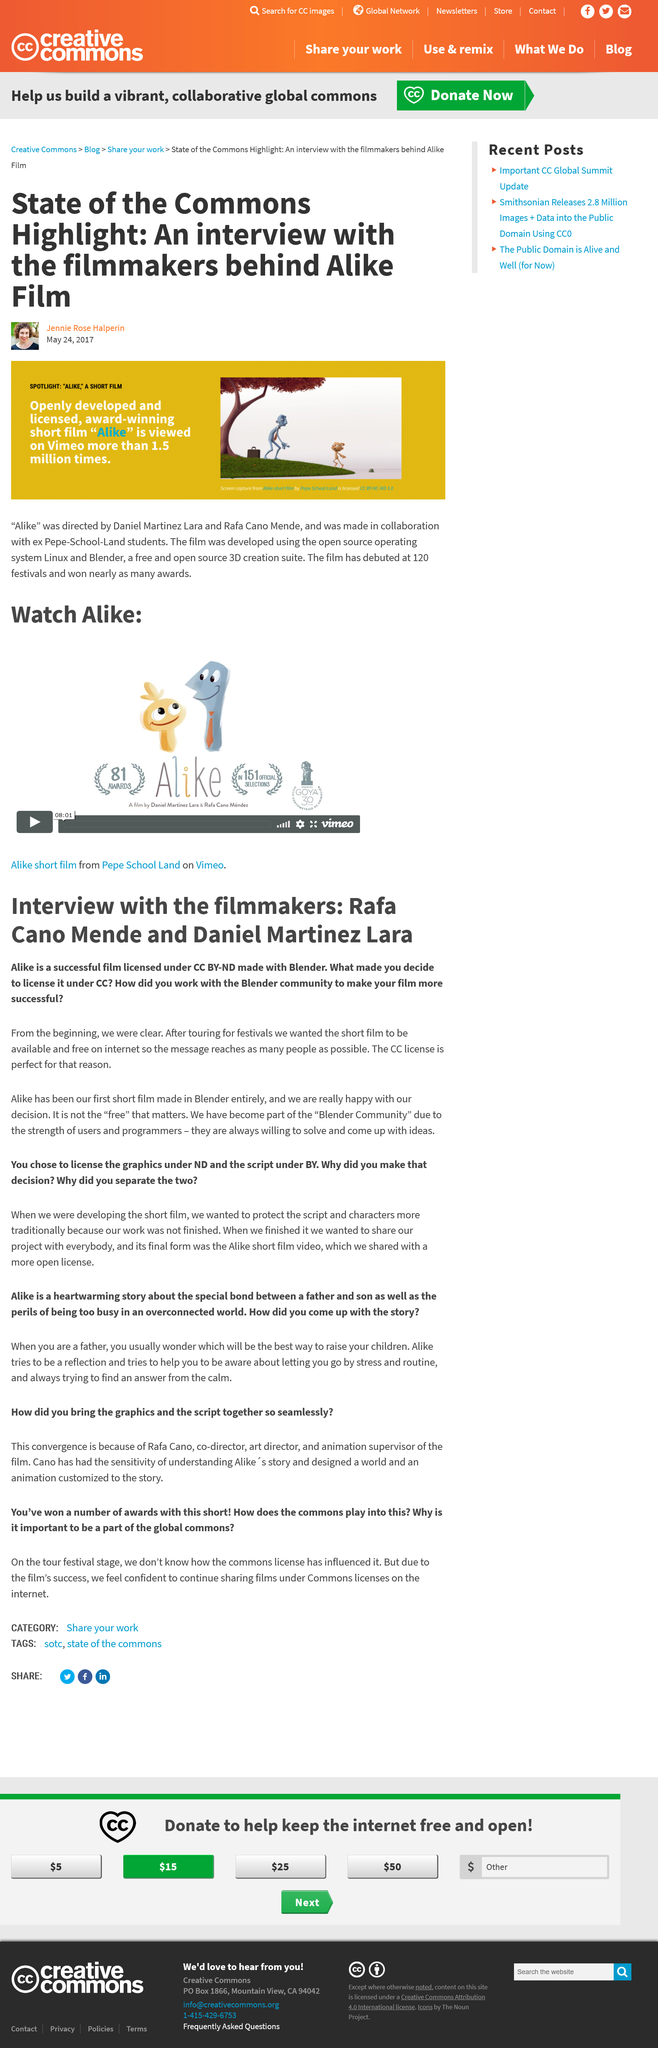List a handful of essential elements in this visual. I, [insert name], declare that the title of the film made by Rafa Cano Mende and Daniel Martinez Lara is 'Alike'. Is "Alike" a full-length feature film or a short film?" The answer is clear: "Alike" is a short film. The directors used Linux and Blender to create a short film that has garnered 1.5 million views on Vimeo. The film 'Alike' was licensed under a Creative Commons Attribution-NonCommercial license. The directors of the film "Alike" are Daniel Martinez Lara and Rafa Cano Mendez. 